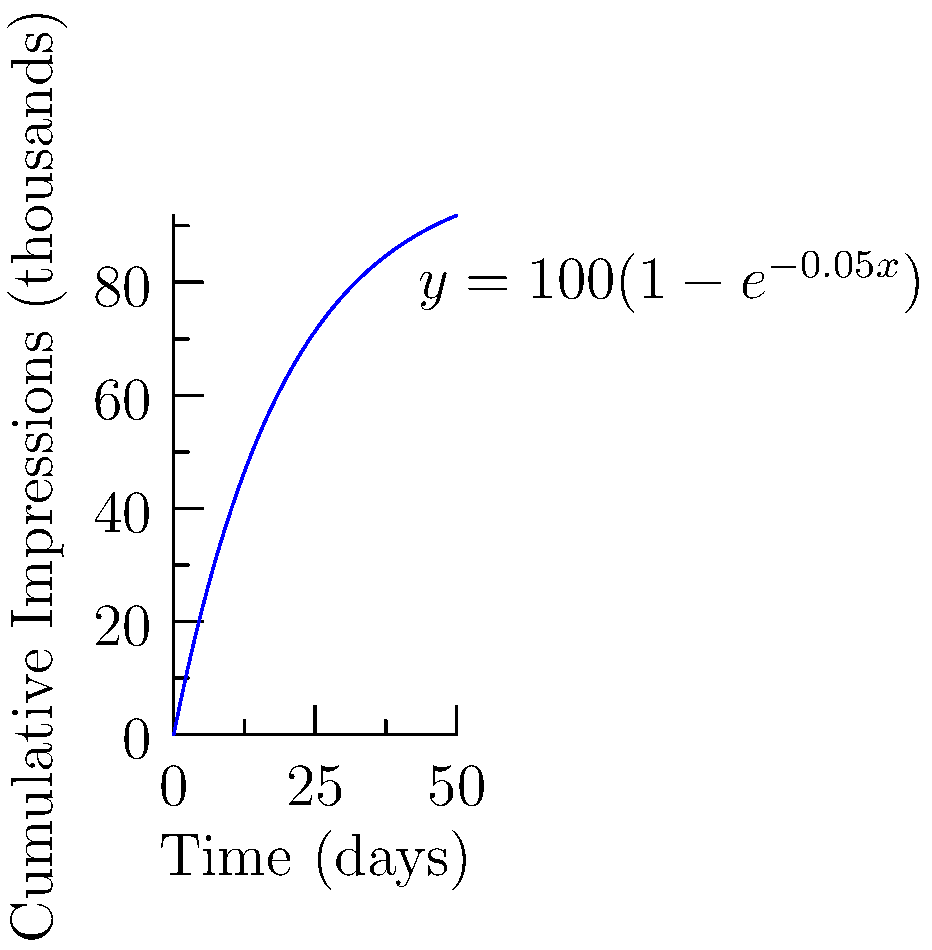As a social scientist studying the impact of social media, you're analyzing the cumulative effect of impressions over time for a viral post. The growth of impressions can be modeled by the function $f(t) = 100(1-e^{-0.05t})$, where $t$ is time in days and $f(t)$ is the cumulative number of impressions in thousands. Calculate the total number of impressions gained between day 10 and day 30. To find the total number of impressions gained between day 10 and day 30, we need to calculate the definite integral of the function from t = 10 to t = 30.

1) The function is $f(t) = 100(1-e^{-0.05t})$

2) We need to calculate $\int_{10}^{30} 100(1-e^{-0.05t}) dt$

3) Integrating:
   $\int 100(1-e^{-0.05t}) dt = 100t + 2000e^{-0.05t} + C$

4) Applying the limits:
   $[100t + 2000e^{-0.05t}]_{10}^{30}$

5) Evaluating:
   $(3000 + 2000e^{-1.5}) - (1000 + 2000e^{-0.5})$

6) Simplifying:
   $3000 + 2000e^{-1.5} - 1000 - 2000e^{-0.5}$
   $= 2000 + 2000(e^{-1.5} - e^{-0.5})$

7) Calculating:
   $\approx 2000 + 2000(0.2231 - 0.6065)$
   $\approx 2000 - 766.8$
   $\approx 1233.2$

Therefore, the total number of impressions gained between day 10 and day 30 is approximately 1233.2 thousand, or 1,233,200 impressions.
Answer: 1,233,200 impressions 